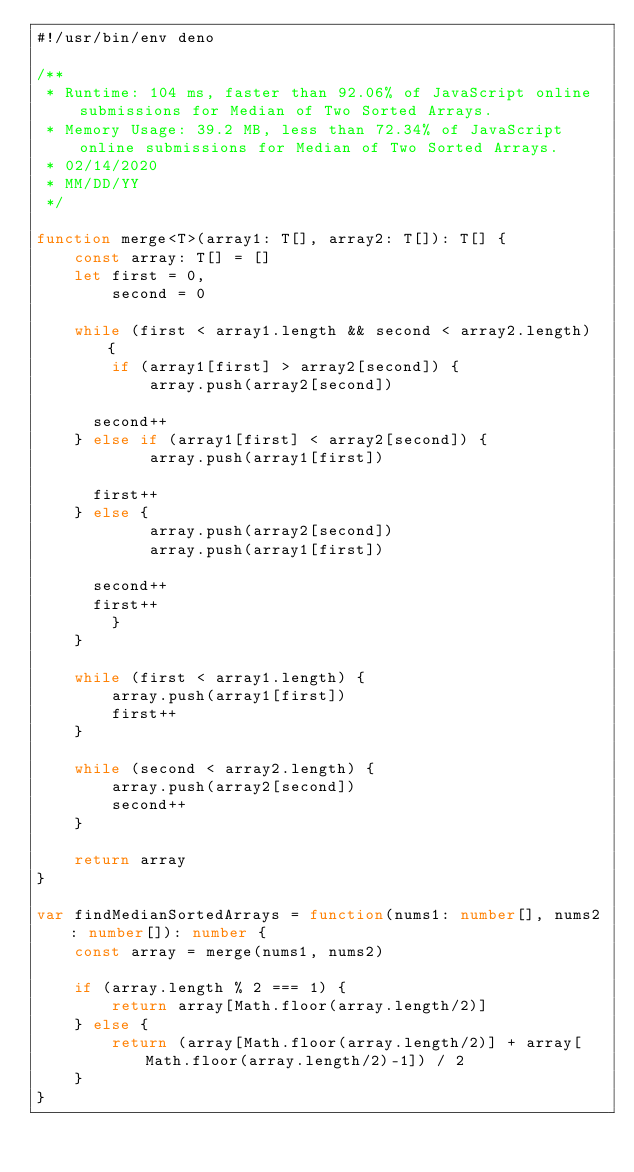Convert code to text. <code><loc_0><loc_0><loc_500><loc_500><_TypeScript_>#!/usr/bin/env deno

/**
 * Runtime: 104 ms, faster than 92.06% of JavaScript online submissions for Median of Two Sorted Arrays.
 * Memory Usage: 39.2 MB, less than 72.34% of JavaScript online submissions for Median of Two Sorted Arrays.
 * 02/14/2020
 * MM/DD/YY
 */

function merge<T>(array1: T[], array2: T[]): T[] {
    const array: T[] = []
    let first = 0,
        second = 0

    while (first < array1.length && second < array2.length) {
        if (array1[first] > array2[second]) {
            array.push(array2[second])

			second++
		} else if (array1[first] < array2[second]) {
            array.push(array1[first])

			first++
		} else {
            array.push(array2[second])
            array.push(array1[first])

			second++
			first++
        }
    }

    while (first < array1.length) {
        array.push(array1[first])
        first++
    }

    while (second < array2.length) {
        array.push(array2[second])
        second++
    }

    return array
}

var findMedianSortedArrays = function(nums1: number[], nums2: number[]): number {
    const array = merge(nums1, nums2)

    if (array.length % 2 === 1) {
        return array[Math.floor(array.length/2)]
    } else {
        return (array[Math.floor(array.length/2)] + array[Math.floor(array.length/2)-1]) / 2
    }
}
</code> 